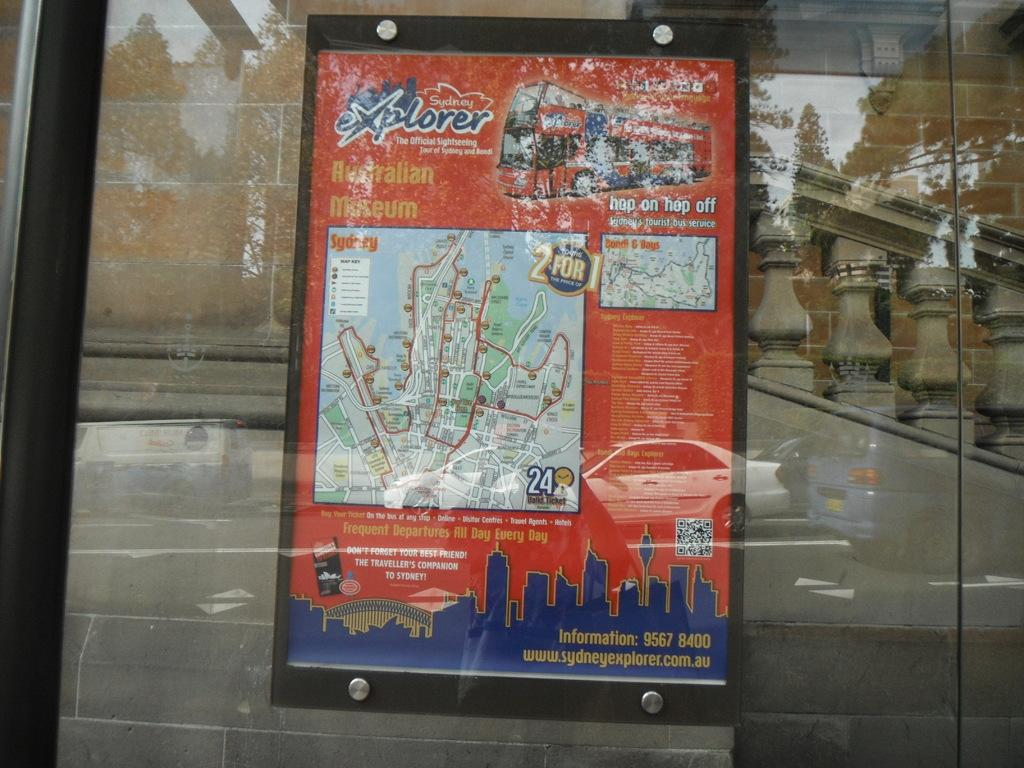<image>
Summarize the visual content of the image. Sydney Explorer sign in a frame on a glass window. 